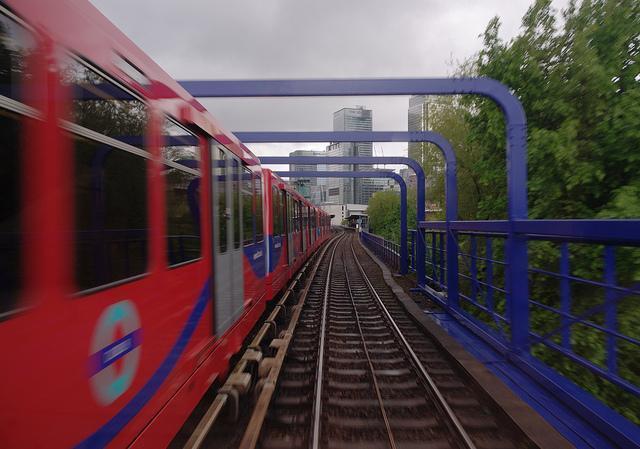How many elbows are hanging out the windows?
Give a very brief answer. 0. 